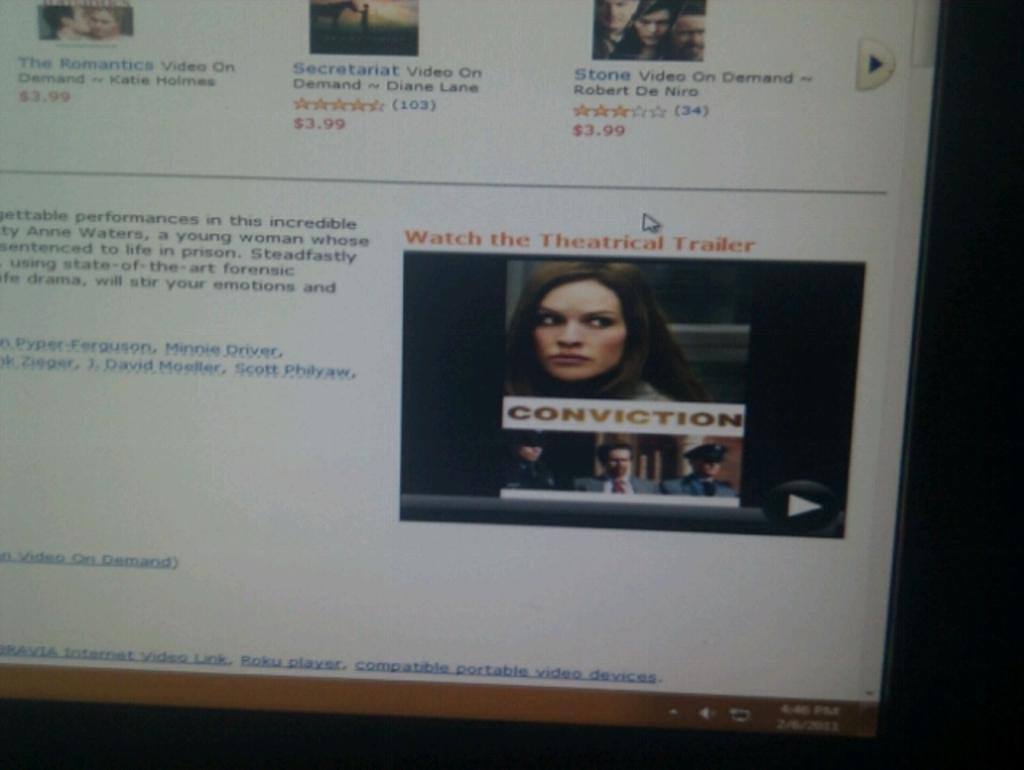Can you describe this image briefly? In this picture we can see a screen, there is a web page opened in the screen, we can see some text on the left side, on the right side there are depictions of persons, at the bottom we can see time and date, we can also see icons. 